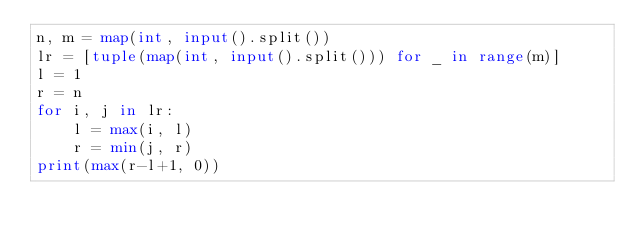<code> <loc_0><loc_0><loc_500><loc_500><_Python_>n, m = map(int, input().split())
lr = [tuple(map(int, input().split())) for _ in range(m)]
l = 1
r = n
for i, j in lr:
    l = max(i, l)
    r = min(j, r)
print(max(r-l+1, 0))
</code> 